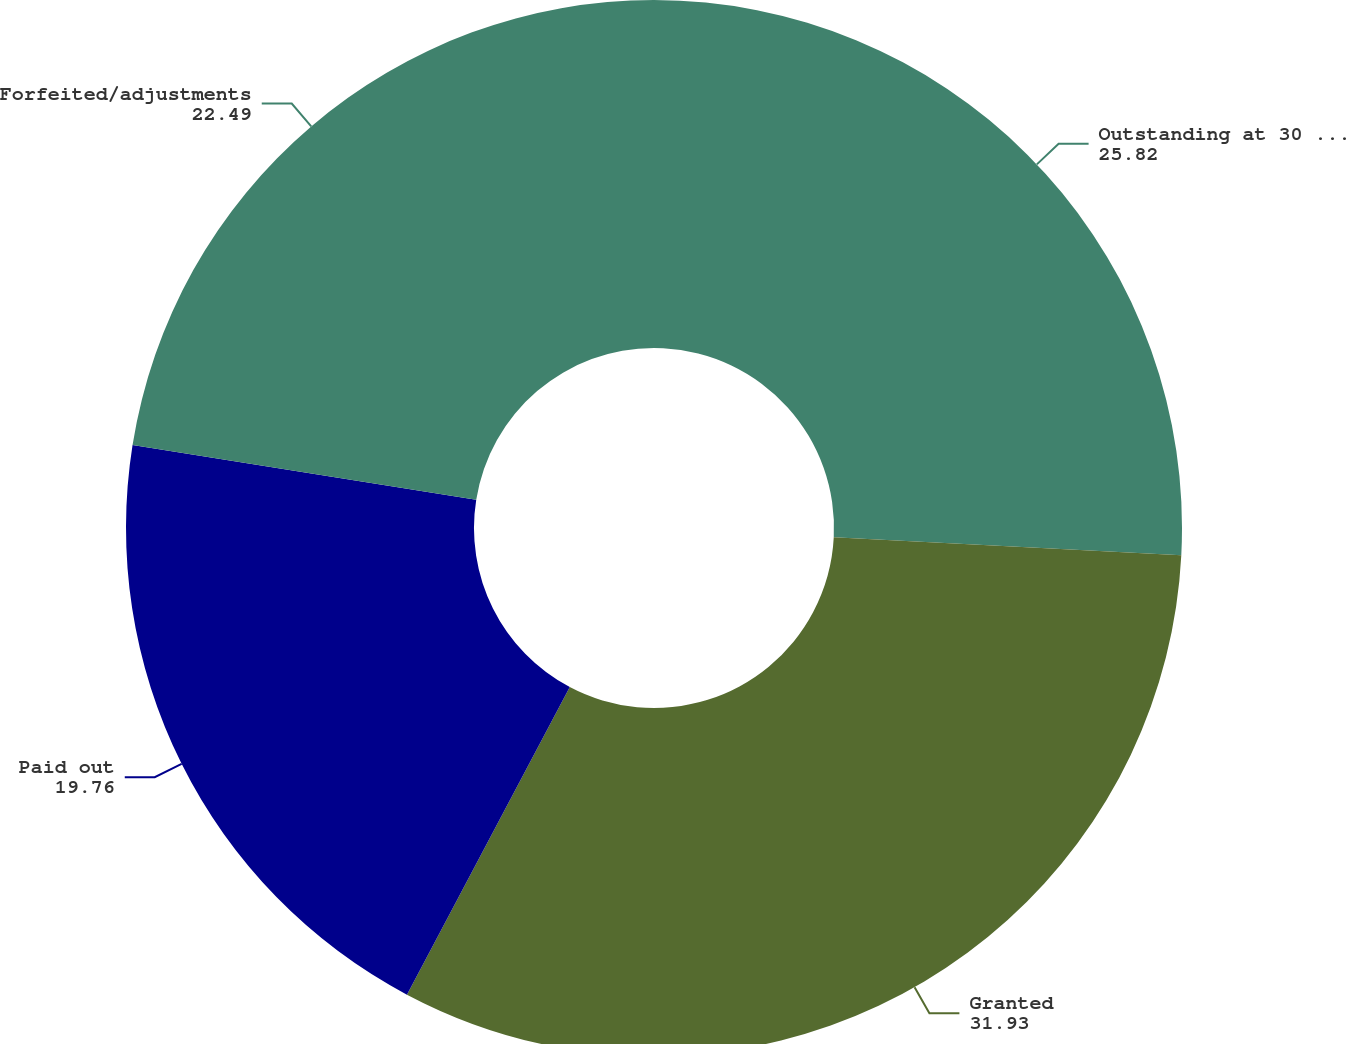Convert chart. <chart><loc_0><loc_0><loc_500><loc_500><pie_chart><fcel>Outstanding at 30 September<fcel>Granted<fcel>Paid out<fcel>Forfeited/adjustments<nl><fcel>25.82%<fcel>31.93%<fcel>19.76%<fcel>22.49%<nl></chart> 